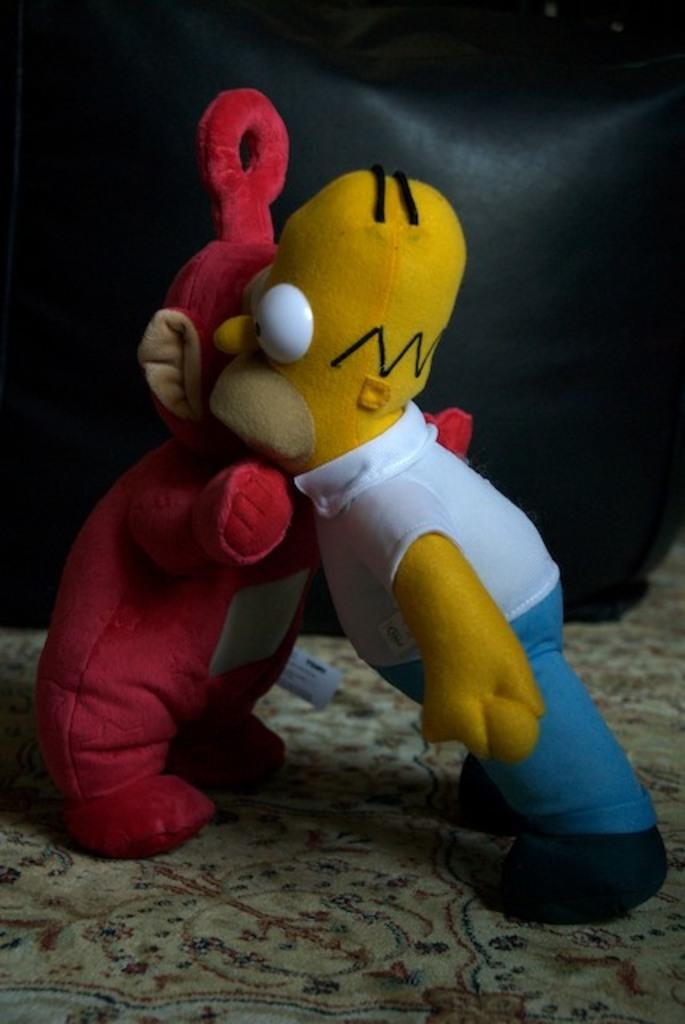How many toys can be seen in the image? There are two toys in the image. What is the surface on which the toys are standing? The toys are standing on a carpet. Can you describe the background of the image? There is a black color object in the background of the image. Are there any fairies visible in the image? No, there are no fairies present in the image. What type of acoustics can be heard in the image? There is no sound or acoustics mentioned in the image, so it cannot be determined from the image. 